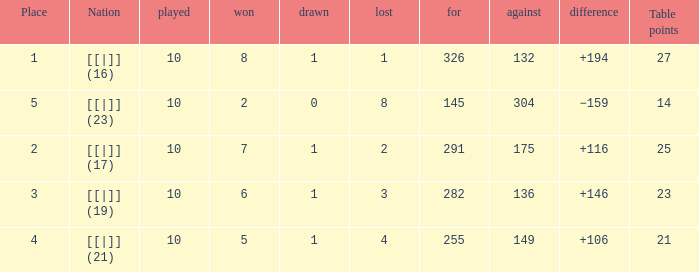 How many table points are listed for the deficit is +194?  1.0. 